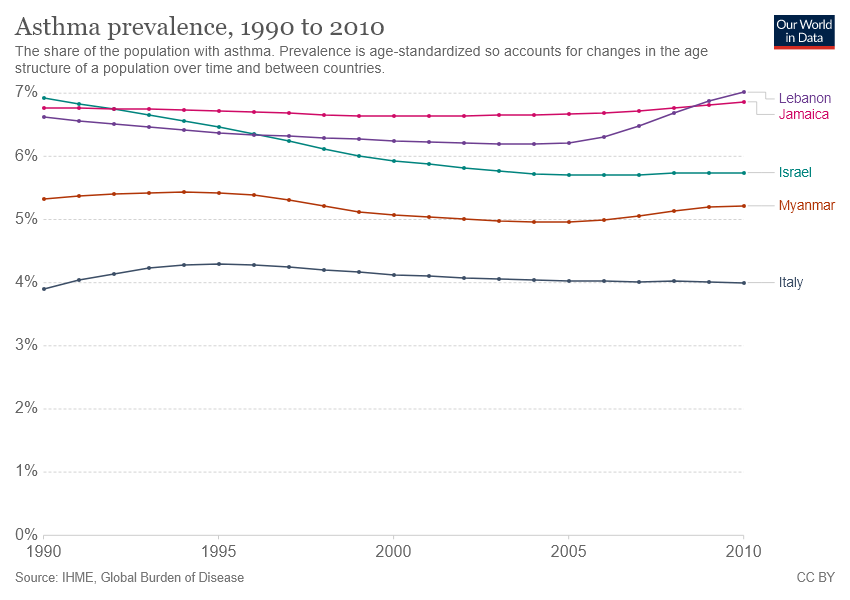Point out several critical features in this image. I'm sorry, but the sentence you provided is not grammatically correct. Could you please provide a more complete sentence or clarify what you are asking? In the year 2010, the highest number of diseases were prevented. 